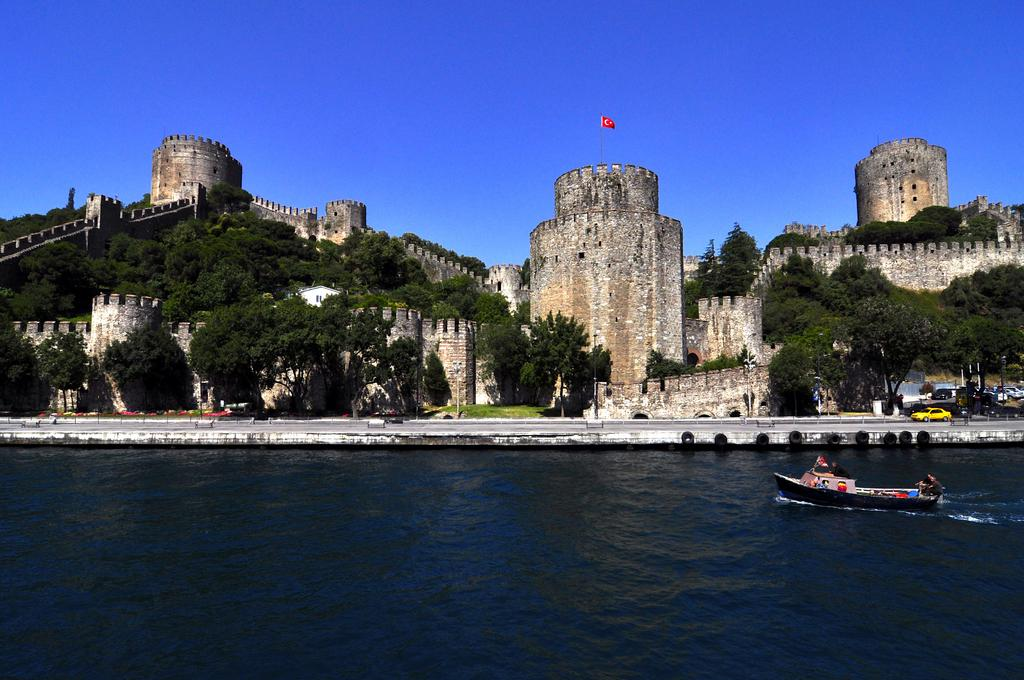What type of structure is in the picture? There is a fort in the picture. What is flying near the fort? There is a flag in the picture. What type of natural environment is visible in the picture? There are trees in the picture. What type of vehicles are in the picture? There are cars in the picture. What type of watercraft is in the picture? There is a boat on the water. Are there any people in the boat? Yes, there are people in the boat. What is the color of the sky in the picture? The sky is blue. What type of metal is being used to show respect in the image? There is no metal being used to show respect in the image. Can you provide an example of a person in the image who is not present? There are no people in the image who are not present, as all people visible in the image are accounted for. 